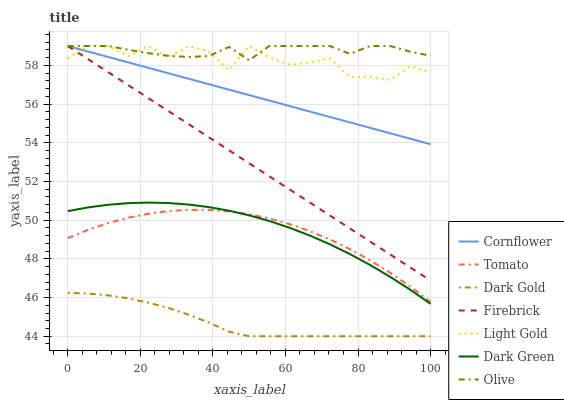Does Dark Gold have the minimum area under the curve?
Answer yes or no. Yes. Does Olive have the maximum area under the curve?
Answer yes or no. Yes. Does Cornflower have the minimum area under the curve?
Answer yes or no. No. Does Cornflower have the maximum area under the curve?
Answer yes or no. No. Is Cornflower the smoothest?
Answer yes or no. Yes. Is Light Gold the roughest?
Answer yes or no. Yes. Is Dark Gold the smoothest?
Answer yes or no. No. Is Dark Gold the roughest?
Answer yes or no. No. Does Dark Gold have the lowest value?
Answer yes or no. Yes. Does Cornflower have the lowest value?
Answer yes or no. No. Does Light Gold have the highest value?
Answer yes or no. Yes. Does Dark Gold have the highest value?
Answer yes or no. No. Is Tomato less than Light Gold?
Answer yes or no. Yes. Is Firebrick greater than Tomato?
Answer yes or no. Yes. Does Cornflower intersect Olive?
Answer yes or no. Yes. Is Cornflower less than Olive?
Answer yes or no. No. Is Cornflower greater than Olive?
Answer yes or no. No. Does Tomato intersect Light Gold?
Answer yes or no. No. 